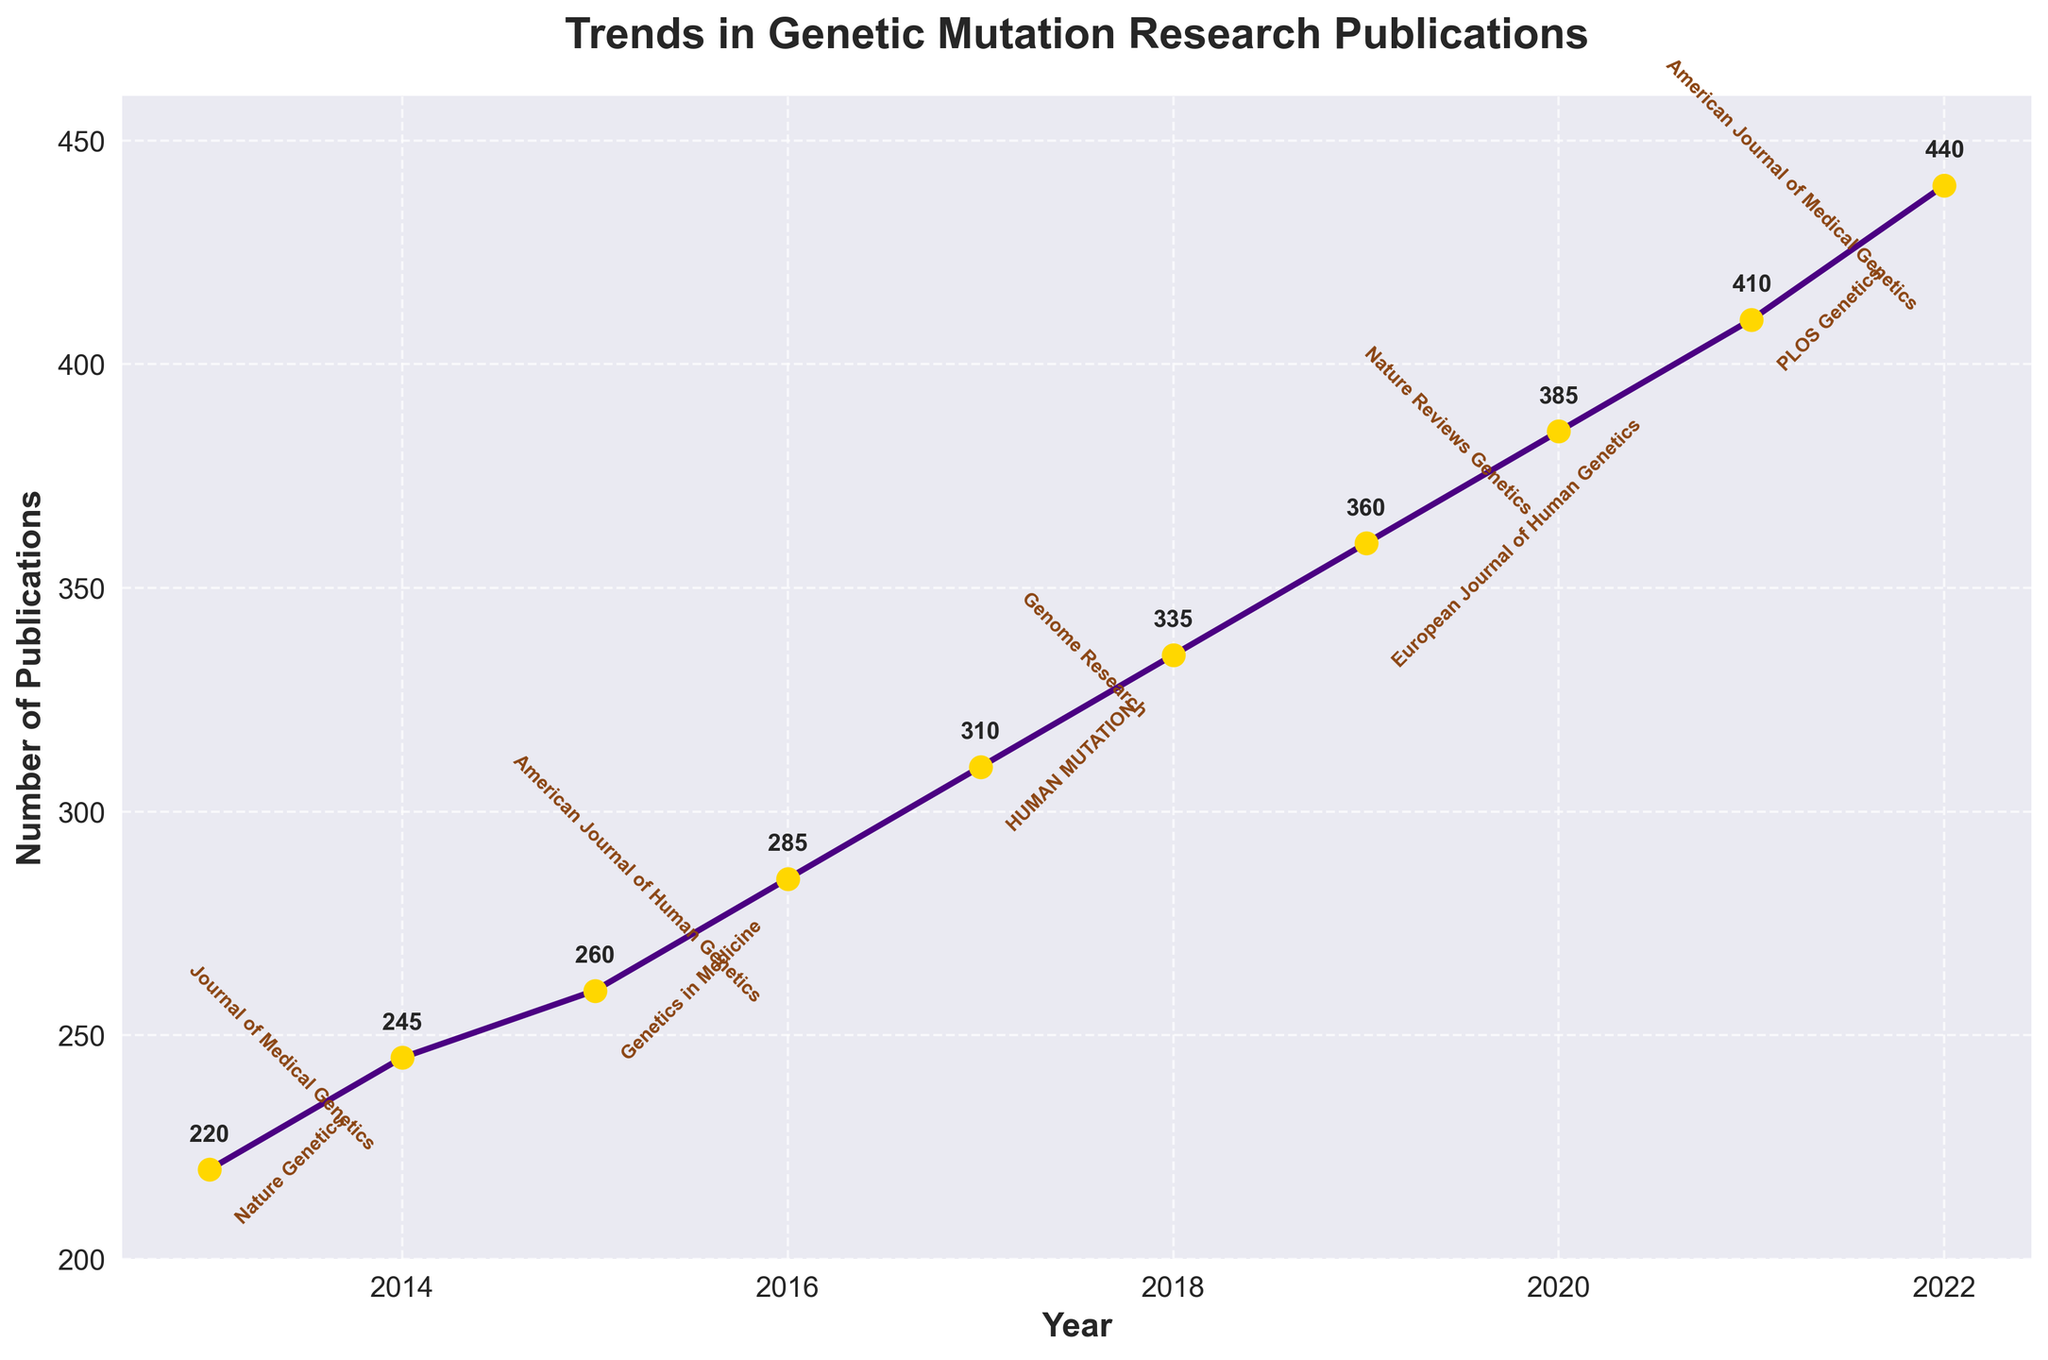What is the title of the plot? The title, typically displayed at the top of the plot, reads "Trends in Genetic Mutation Research Publications".
Answer: Trends in Genetic Mutation Research Publications How many years are covered in this plot? The plot displays yearly data from 2013 to 2022, which are 10 years in total.
Answer: 10 In which year was the publication count the highest? The highest point on the plot corresponds to the year 2022, with 440 publications.
Answer: 2022 How many publications were there in 2017? The point for the year 2017 is labeled with the number 310 next to it.
Answer: 310 What was the trend in publication count from 2015 to 2018? By observing the plot, the publication counts increase each year from 260 in 2015 to 335 in 2018, indicating an upward trend.
Answer: Upward Which year had the highest increase in publication count compared to the previous year? Calculating the differences year by year, the highest increase is from 2021 (410) to 2022 (440), which is 30 publications.
Answer: 2022 Which journals are associated with the publication counts in 2018 and 2021? In 2018, the journal is "Genome Research," and in 2021, it is "PLOS Genetics," as annotated near the respective data points on the plot.
Answer: Genome Research, PLOS Genetics Compare the publication counts in 2013 and 2020. What can you infer? In 2013, the count is 220, and in 2020, it is 385. The publication count almost doubled over the 7-year period.
Answer: Nearly doubled What is the average number of publications over the decade? Sum of publications from 2013 to 2022 is 3240. Dividing by 10 years, the average is 324.
Answer: 324 Did any year have fewer than 250 publications? If so, which year(s)? Observing the plot, the publication counts for years 2013 (220) and 2014 (245) are below 250.
Answer: 2013, 2014 